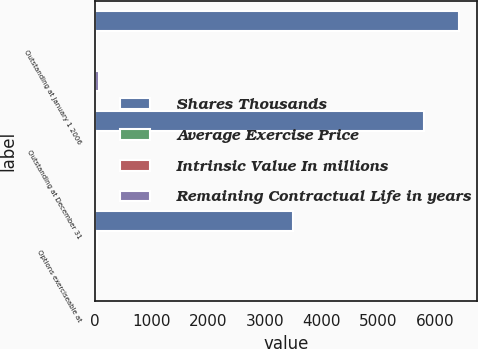Convert chart to OTSL. <chart><loc_0><loc_0><loc_500><loc_500><stacked_bar_chart><ecel><fcel>Outstanding at January 1 2006<fcel>Outstanding at December 31<fcel>Options exerciseable at<nl><fcel>Shares Thousands<fcel>6418<fcel>5798<fcel>3487<nl><fcel>Average Exercise Price<fcel>21.21<fcel>27.86<fcel>24.38<nl><fcel>Intrinsic Value In millions<fcel>8.1<fcel>6.7<fcel>5.9<nl><fcel>Remaining Contractual Life in years<fcel>58.5<fcel>6<fcel>6<nl></chart> 